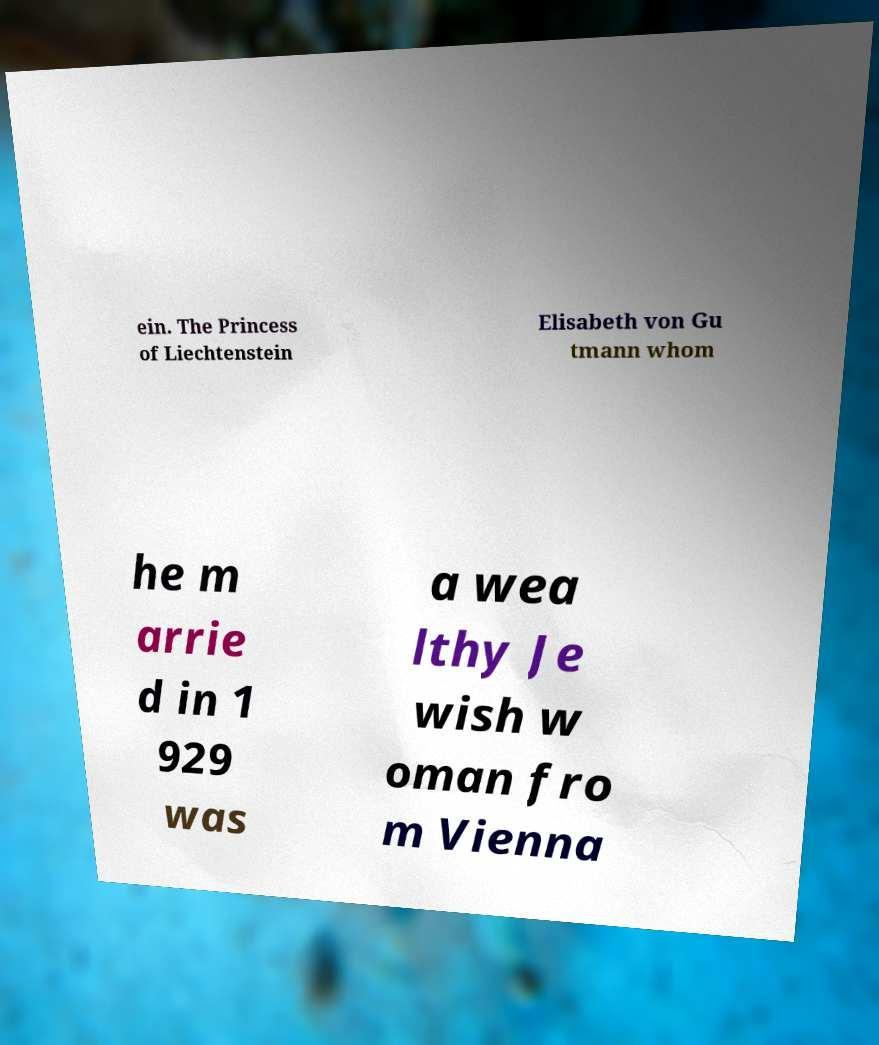Can you read and provide the text displayed in the image?This photo seems to have some interesting text. Can you extract and type it out for me? ein. The Princess of Liechtenstein Elisabeth von Gu tmann whom he m arrie d in 1 929 was a wea lthy Je wish w oman fro m Vienna 